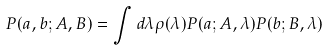Convert formula to latex. <formula><loc_0><loc_0><loc_500><loc_500>P ( a , b ; A , B ) = \int d \lambda \rho ( \lambda ) P ( a ; A , \lambda ) P ( b ; B , \lambda )</formula> 